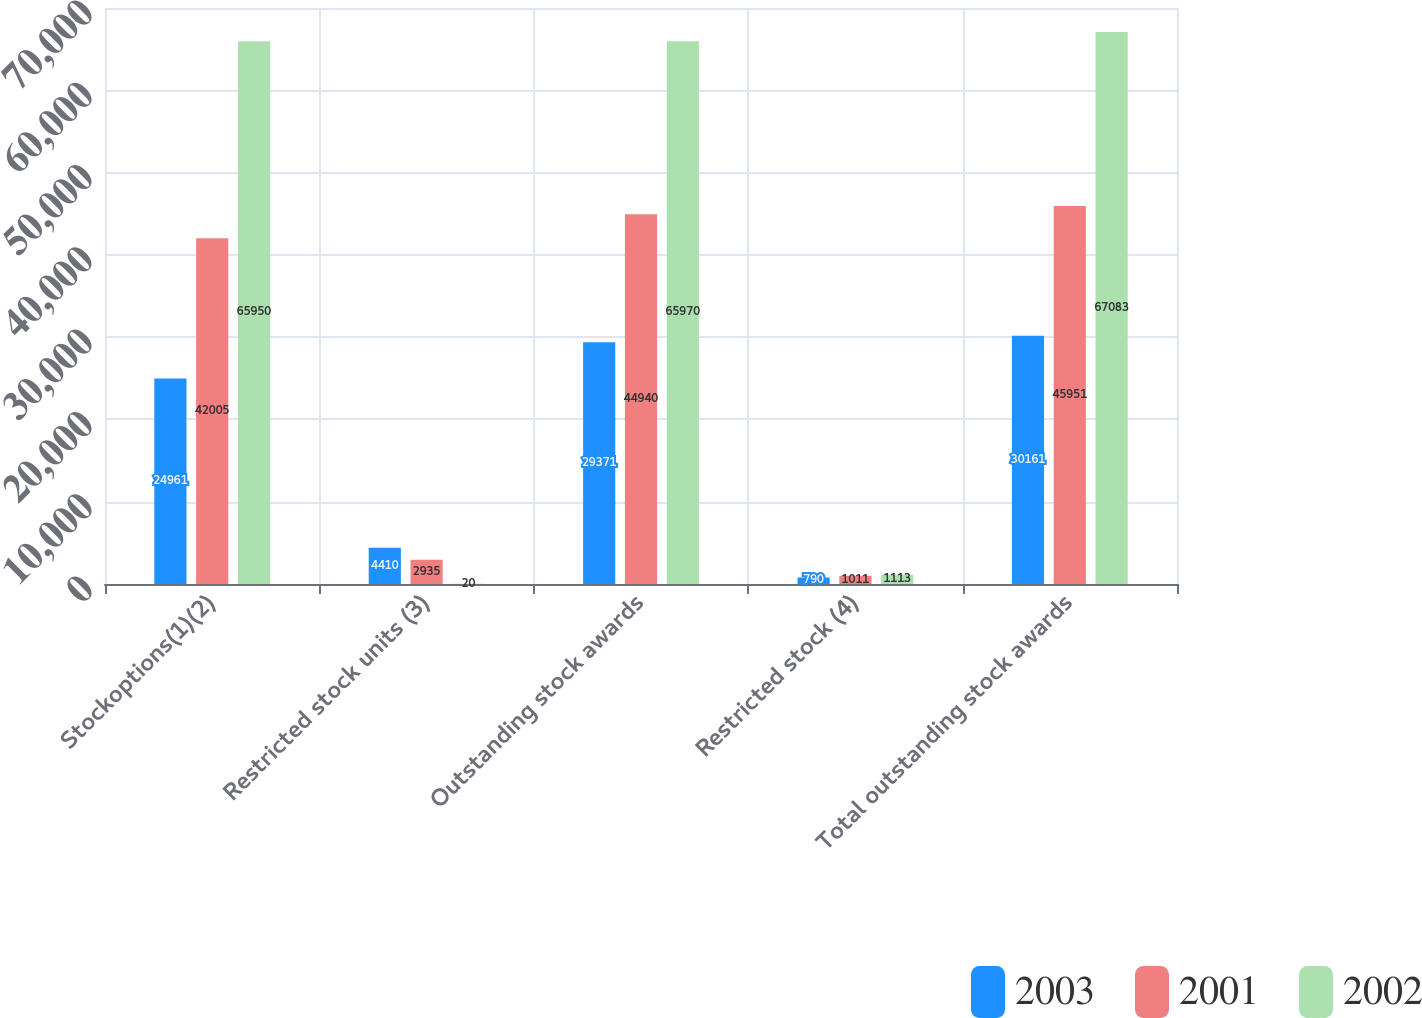Convert chart. <chart><loc_0><loc_0><loc_500><loc_500><stacked_bar_chart><ecel><fcel>Stockoptions(1)(2)<fcel>Restricted stock units (3)<fcel>Outstanding stock awards<fcel>Restricted stock (4)<fcel>Total outstanding stock awards<nl><fcel>2003<fcel>24961<fcel>4410<fcel>29371<fcel>790<fcel>30161<nl><fcel>2001<fcel>42005<fcel>2935<fcel>44940<fcel>1011<fcel>45951<nl><fcel>2002<fcel>65950<fcel>20<fcel>65970<fcel>1113<fcel>67083<nl></chart> 